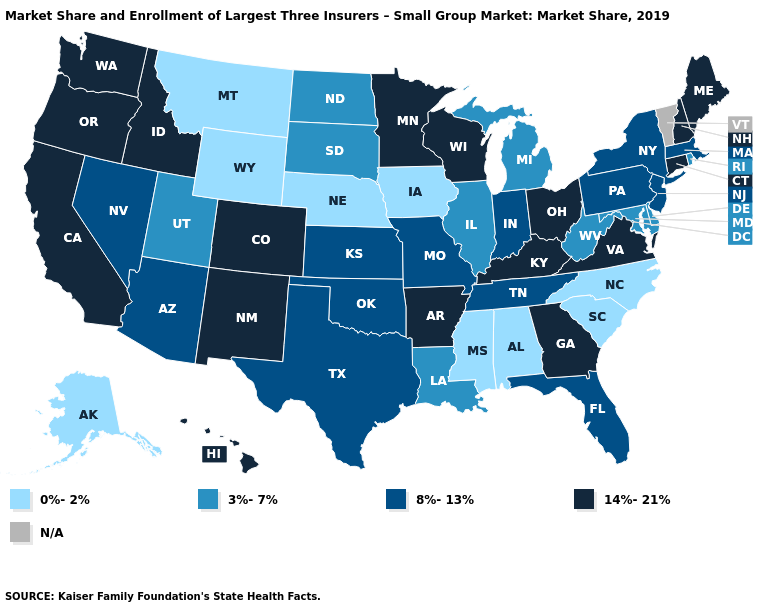Name the states that have a value in the range 14%-21%?
Concise answer only. Arkansas, California, Colorado, Connecticut, Georgia, Hawaii, Idaho, Kentucky, Maine, Minnesota, New Hampshire, New Mexico, Ohio, Oregon, Virginia, Washington, Wisconsin. Does the first symbol in the legend represent the smallest category?
Give a very brief answer. Yes. Does Alabama have the highest value in the South?
Write a very short answer. No. Does Colorado have the highest value in the West?
Keep it brief. Yes. What is the value of Kentucky?
Concise answer only. 14%-21%. What is the value of South Dakota?
Write a very short answer. 3%-7%. What is the value of Montana?
Write a very short answer. 0%-2%. Which states have the lowest value in the USA?
Write a very short answer. Alabama, Alaska, Iowa, Mississippi, Montana, Nebraska, North Carolina, South Carolina, Wyoming. Which states have the lowest value in the Northeast?
Be succinct. Rhode Island. Which states hav the highest value in the South?
Answer briefly. Arkansas, Georgia, Kentucky, Virginia. What is the highest value in states that border South Dakota?
Give a very brief answer. 14%-21%. What is the lowest value in the USA?
Quick response, please. 0%-2%. Does the map have missing data?
Short answer required. Yes. 